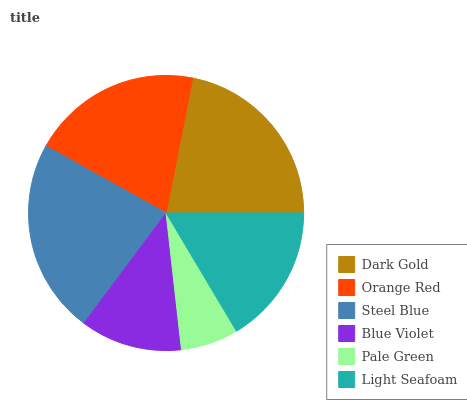Is Pale Green the minimum?
Answer yes or no. Yes. Is Steel Blue the maximum?
Answer yes or no. Yes. Is Orange Red the minimum?
Answer yes or no. No. Is Orange Red the maximum?
Answer yes or no. No. Is Dark Gold greater than Orange Red?
Answer yes or no. Yes. Is Orange Red less than Dark Gold?
Answer yes or no. Yes. Is Orange Red greater than Dark Gold?
Answer yes or no. No. Is Dark Gold less than Orange Red?
Answer yes or no. No. Is Orange Red the high median?
Answer yes or no. Yes. Is Light Seafoam the low median?
Answer yes or no. Yes. Is Blue Violet the high median?
Answer yes or no. No. Is Pale Green the low median?
Answer yes or no. No. 